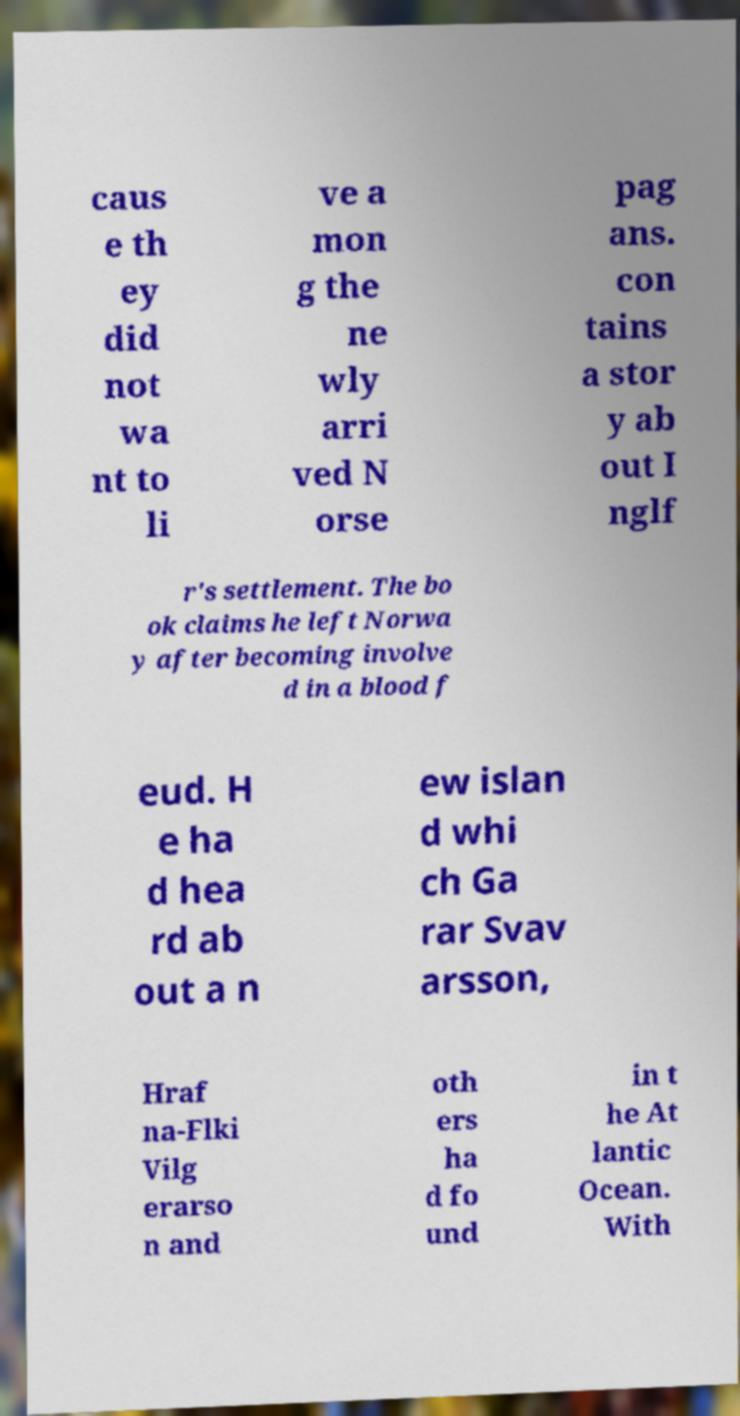Can you read and provide the text displayed in the image?This photo seems to have some interesting text. Can you extract and type it out for me? caus e th ey did not wa nt to li ve a mon g the ne wly arri ved N orse pag ans. con tains a stor y ab out I nglf r's settlement. The bo ok claims he left Norwa y after becoming involve d in a blood f eud. H e ha d hea rd ab out a n ew islan d whi ch Ga rar Svav arsson, Hraf na-Flki Vilg erarso n and oth ers ha d fo und in t he At lantic Ocean. With 